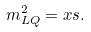<formula> <loc_0><loc_0><loc_500><loc_500>m ^ { 2 } _ { L Q } = x s .</formula> 